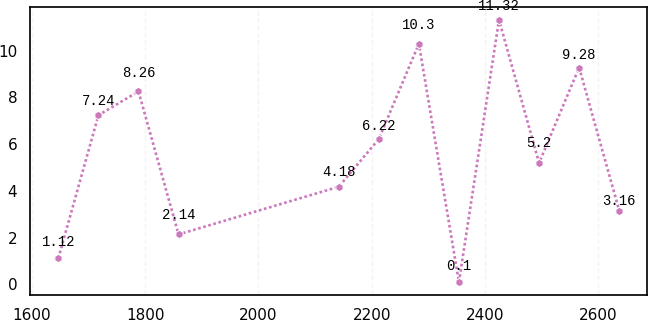<chart> <loc_0><loc_0><loc_500><loc_500><line_chart><ecel><fcel>Unnamed: 1<nl><fcel>1646.65<fcel>1.12<nl><fcel>1717.42<fcel>7.24<nl><fcel>1788.19<fcel>8.26<nl><fcel>1858.96<fcel>2.14<nl><fcel>2141.91<fcel>4.18<nl><fcel>2212.68<fcel>6.22<nl><fcel>2283.45<fcel>10.3<nl><fcel>2354.22<fcel>0.1<nl><fcel>2424.99<fcel>11.32<nl><fcel>2495.76<fcel>5.2<nl><fcel>2566.53<fcel>9.28<nl><fcel>2637.3<fcel>3.16<nl></chart> 